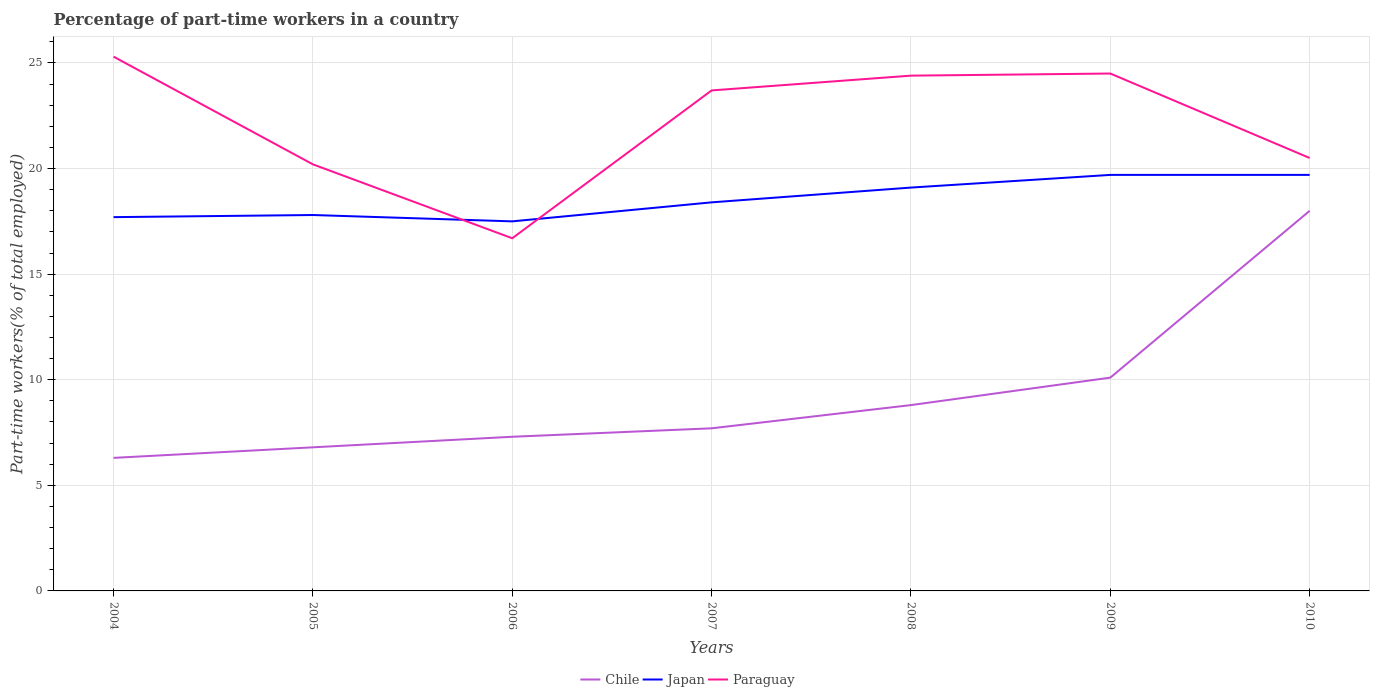Is the number of lines equal to the number of legend labels?
Your answer should be compact. Yes. Across all years, what is the maximum percentage of part-time workers in Japan?
Your response must be concise. 17.5. In which year was the percentage of part-time workers in Chile maximum?
Your answer should be compact. 2004. What is the difference between the highest and the second highest percentage of part-time workers in Paraguay?
Ensure brevity in your answer.  8.6. What is the difference between the highest and the lowest percentage of part-time workers in Chile?
Provide a short and direct response. 2. Is the percentage of part-time workers in Chile strictly greater than the percentage of part-time workers in Paraguay over the years?
Your answer should be very brief. Yes. How many lines are there?
Your answer should be very brief. 3. How many years are there in the graph?
Your response must be concise. 7. What is the difference between two consecutive major ticks on the Y-axis?
Make the answer very short. 5. Are the values on the major ticks of Y-axis written in scientific E-notation?
Provide a succinct answer. No. Does the graph contain grids?
Give a very brief answer. Yes. What is the title of the graph?
Keep it short and to the point. Percentage of part-time workers in a country. Does "Djibouti" appear as one of the legend labels in the graph?
Provide a succinct answer. No. What is the label or title of the X-axis?
Provide a succinct answer. Years. What is the label or title of the Y-axis?
Offer a terse response. Part-time workers(% of total employed). What is the Part-time workers(% of total employed) of Chile in 2004?
Ensure brevity in your answer.  6.3. What is the Part-time workers(% of total employed) of Japan in 2004?
Offer a terse response. 17.7. What is the Part-time workers(% of total employed) in Paraguay in 2004?
Your answer should be compact. 25.3. What is the Part-time workers(% of total employed) in Chile in 2005?
Provide a short and direct response. 6.8. What is the Part-time workers(% of total employed) in Japan in 2005?
Your answer should be very brief. 17.8. What is the Part-time workers(% of total employed) of Paraguay in 2005?
Provide a short and direct response. 20.2. What is the Part-time workers(% of total employed) of Chile in 2006?
Provide a succinct answer. 7.3. What is the Part-time workers(% of total employed) of Paraguay in 2006?
Offer a very short reply. 16.7. What is the Part-time workers(% of total employed) of Chile in 2007?
Ensure brevity in your answer.  7.7. What is the Part-time workers(% of total employed) of Japan in 2007?
Provide a short and direct response. 18.4. What is the Part-time workers(% of total employed) of Paraguay in 2007?
Keep it short and to the point. 23.7. What is the Part-time workers(% of total employed) of Chile in 2008?
Provide a short and direct response. 8.8. What is the Part-time workers(% of total employed) of Japan in 2008?
Your answer should be compact. 19.1. What is the Part-time workers(% of total employed) of Paraguay in 2008?
Offer a very short reply. 24.4. What is the Part-time workers(% of total employed) of Chile in 2009?
Make the answer very short. 10.1. What is the Part-time workers(% of total employed) in Japan in 2009?
Offer a terse response. 19.7. What is the Part-time workers(% of total employed) of Japan in 2010?
Your answer should be very brief. 19.7. Across all years, what is the maximum Part-time workers(% of total employed) of Chile?
Your answer should be compact. 18. Across all years, what is the maximum Part-time workers(% of total employed) of Japan?
Provide a succinct answer. 19.7. Across all years, what is the maximum Part-time workers(% of total employed) of Paraguay?
Keep it short and to the point. 25.3. Across all years, what is the minimum Part-time workers(% of total employed) in Chile?
Offer a very short reply. 6.3. Across all years, what is the minimum Part-time workers(% of total employed) of Paraguay?
Offer a very short reply. 16.7. What is the total Part-time workers(% of total employed) in Japan in the graph?
Provide a succinct answer. 129.9. What is the total Part-time workers(% of total employed) in Paraguay in the graph?
Ensure brevity in your answer.  155.3. What is the difference between the Part-time workers(% of total employed) of Chile in 2004 and that in 2005?
Your answer should be compact. -0.5. What is the difference between the Part-time workers(% of total employed) in Chile in 2004 and that in 2006?
Provide a succinct answer. -1. What is the difference between the Part-time workers(% of total employed) in Paraguay in 2004 and that in 2006?
Offer a very short reply. 8.6. What is the difference between the Part-time workers(% of total employed) in Japan in 2004 and that in 2007?
Provide a short and direct response. -0.7. What is the difference between the Part-time workers(% of total employed) of Paraguay in 2004 and that in 2007?
Offer a very short reply. 1.6. What is the difference between the Part-time workers(% of total employed) in Chile in 2004 and that in 2008?
Provide a succinct answer. -2.5. What is the difference between the Part-time workers(% of total employed) in Japan in 2004 and that in 2008?
Your response must be concise. -1.4. What is the difference between the Part-time workers(% of total employed) in Paraguay in 2004 and that in 2008?
Give a very brief answer. 0.9. What is the difference between the Part-time workers(% of total employed) of Chile in 2004 and that in 2009?
Your response must be concise. -3.8. What is the difference between the Part-time workers(% of total employed) in Japan in 2004 and that in 2009?
Keep it short and to the point. -2. What is the difference between the Part-time workers(% of total employed) of Paraguay in 2004 and that in 2010?
Make the answer very short. 4.8. What is the difference between the Part-time workers(% of total employed) of Japan in 2005 and that in 2006?
Keep it short and to the point. 0.3. What is the difference between the Part-time workers(% of total employed) in Paraguay in 2005 and that in 2006?
Keep it short and to the point. 3.5. What is the difference between the Part-time workers(% of total employed) in Chile in 2005 and that in 2007?
Offer a terse response. -0.9. What is the difference between the Part-time workers(% of total employed) of Japan in 2005 and that in 2007?
Ensure brevity in your answer.  -0.6. What is the difference between the Part-time workers(% of total employed) in Paraguay in 2005 and that in 2007?
Your answer should be very brief. -3.5. What is the difference between the Part-time workers(% of total employed) of Chile in 2005 and that in 2008?
Your answer should be compact. -2. What is the difference between the Part-time workers(% of total employed) of Japan in 2005 and that in 2008?
Provide a short and direct response. -1.3. What is the difference between the Part-time workers(% of total employed) of Paraguay in 2005 and that in 2009?
Give a very brief answer. -4.3. What is the difference between the Part-time workers(% of total employed) of Chile in 2005 and that in 2010?
Give a very brief answer. -11.2. What is the difference between the Part-time workers(% of total employed) in Japan in 2005 and that in 2010?
Make the answer very short. -1.9. What is the difference between the Part-time workers(% of total employed) in Paraguay in 2005 and that in 2010?
Offer a terse response. -0.3. What is the difference between the Part-time workers(% of total employed) of Chile in 2006 and that in 2007?
Offer a very short reply. -0.4. What is the difference between the Part-time workers(% of total employed) in Japan in 2006 and that in 2007?
Your response must be concise. -0.9. What is the difference between the Part-time workers(% of total employed) in Paraguay in 2006 and that in 2007?
Your response must be concise. -7. What is the difference between the Part-time workers(% of total employed) in Chile in 2006 and that in 2008?
Your answer should be compact. -1.5. What is the difference between the Part-time workers(% of total employed) in Paraguay in 2006 and that in 2008?
Make the answer very short. -7.7. What is the difference between the Part-time workers(% of total employed) of Japan in 2006 and that in 2009?
Your answer should be very brief. -2.2. What is the difference between the Part-time workers(% of total employed) of Paraguay in 2006 and that in 2009?
Make the answer very short. -7.8. What is the difference between the Part-time workers(% of total employed) in Chile in 2006 and that in 2010?
Ensure brevity in your answer.  -10.7. What is the difference between the Part-time workers(% of total employed) in Japan in 2006 and that in 2010?
Offer a very short reply. -2.2. What is the difference between the Part-time workers(% of total employed) of Paraguay in 2006 and that in 2010?
Give a very brief answer. -3.8. What is the difference between the Part-time workers(% of total employed) in Japan in 2007 and that in 2009?
Make the answer very short. -1.3. What is the difference between the Part-time workers(% of total employed) of Paraguay in 2007 and that in 2009?
Your answer should be very brief. -0.8. What is the difference between the Part-time workers(% of total employed) in Chile in 2007 and that in 2010?
Make the answer very short. -10.3. What is the difference between the Part-time workers(% of total employed) of Japan in 2007 and that in 2010?
Give a very brief answer. -1.3. What is the difference between the Part-time workers(% of total employed) in Japan in 2009 and that in 2010?
Offer a terse response. 0. What is the difference between the Part-time workers(% of total employed) in Chile in 2004 and the Part-time workers(% of total employed) in Japan in 2005?
Your answer should be compact. -11.5. What is the difference between the Part-time workers(% of total employed) in Chile in 2004 and the Part-time workers(% of total employed) in Paraguay in 2005?
Provide a short and direct response. -13.9. What is the difference between the Part-time workers(% of total employed) of Chile in 2004 and the Part-time workers(% of total employed) of Japan in 2006?
Keep it short and to the point. -11.2. What is the difference between the Part-time workers(% of total employed) in Chile in 2004 and the Part-time workers(% of total employed) in Paraguay in 2006?
Your answer should be very brief. -10.4. What is the difference between the Part-time workers(% of total employed) in Chile in 2004 and the Part-time workers(% of total employed) in Japan in 2007?
Offer a terse response. -12.1. What is the difference between the Part-time workers(% of total employed) in Chile in 2004 and the Part-time workers(% of total employed) in Paraguay in 2007?
Offer a terse response. -17.4. What is the difference between the Part-time workers(% of total employed) in Japan in 2004 and the Part-time workers(% of total employed) in Paraguay in 2007?
Your answer should be very brief. -6. What is the difference between the Part-time workers(% of total employed) of Chile in 2004 and the Part-time workers(% of total employed) of Paraguay in 2008?
Keep it short and to the point. -18.1. What is the difference between the Part-time workers(% of total employed) in Chile in 2004 and the Part-time workers(% of total employed) in Paraguay in 2009?
Provide a succinct answer. -18.2. What is the difference between the Part-time workers(% of total employed) in Chile in 2004 and the Part-time workers(% of total employed) in Japan in 2010?
Provide a short and direct response. -13.4. What is the difference between the Part-time workers(% of total employed) in Chile in 2005 and the Part-time workers(% of total employed) in Paraguay in 2006?
Your answer should be compact. -9.9. What is the difference between the Part-time workers(% of total employed) in Japan in 2005 and the Part-time workers(% of total employed) in Paraguay in 2006?
Offer a terse response. 1.1. What is the difference between the Part-time workers(% of total employed) in Chile in 2005 and the Part-time workers(% of total employed) in Japan in 2007?
Provide a short and direct response. -11.6. What is the difference between the Part-time workers(% of total employed) in Chile in 2005 and the Part-time workers(% of total employed) in Paraguay in 2007?
Make the answer very short. -16.9. What is the difference between the Part-time workers(% of total employed) in Japan in 2005 and the Part-time workers(% of total employed) in Paraguay in 2007?
Your response must be concise. -5.9. What is the difference between the Part-time workers(% of total employed) of Chile in 2005 and the Part-time workers(% of total employed) of Paraguay in 2008?
Provide a short and direct response. -17.6. What is the difference between the Part-time workers(% of total employed) of Japan in 2005 and the Part-time workers(% of total employed) of Paraguay in 2008?
Provide a short and direct response. -6.6. What is the difference between the Part-time workers(% of total employed) of Chile in 2005 and the Part-time workers(% of total employed) of Japan in 2009?
Your answer should be very brief. -12.9. What is the difference between the Part-time workers(% of total employed) in Chile in 2005 and the Part-time workers(% of total employed) in Paraguay in 2009?
Your answer should be compact. -17.7. What is the difference between the Part-time workers(% of total employed) of Chile in 2005 and the Part-time workers(% of total employed) of Japan in 2010?
Give a very brief answer. -12.9. What is the difference between the Part-time workers(% of total employed) of Chile in 2005 and the Part-time workers(% of total employed) of Paraguay in 2010?
Provide a succinct answer. -13.7. What is the difference between the Part-time workers(% of total employed) of Japan in 2005 and the Part-time workers(% of total employed) of Paraguay in 2010?
Offer a terse response. -2.7. What is the difference between the Part-time workers(% of total employed) of Chile in 2006 and the Part-time workers(% of total employed) of Paraguay in 2007?
Provide a short and direct response. -16.4. What is the difference between the Part-time workers(% of total employed) of Chile in 2006 and the Part-time workers(% of total employed) of Japan in 2008?
Your response must be concise. -11.8. What is the difference between the Part-time workers(% of total employed) in Chile in 2006 and the Part-time workers(% of total employed) in Paraguay in 2008?
Your response must be concise. -17.1. What is the difference between the Part-time workers(% of total employed) in Chile in 2006 and the Part-time workers(% of total employed) in Japan in 2009?
Keep it short and to the point. -12.4. What is the difference between the Part-time workers(% of total employed) in Chile in 2006 and the Part-time workers(% of total employed) in Paraguay in 2009?
Offer a very short reply. -17.2. What is the difference between the Part-time workers(% of total employed) in Japan in 2006 and the Part-time workers(% of total employed) in Paraguay in 2009?
Provide a short and direct response. -7. What is the difference between the Part-time workers(% of total employed) of Chile in 2006 and the Part-time workers(% of total employed) of Japan in 2010?
Offer a very short reply. -12.4. What is the difference between the Part-time workers(% of total employed) of Chile in 2006 and the Part-time workers(% of total employed) of Paraguay in 2010?
Offer a terse response. -13.2. What is the difference between the Part-time workers(% of total employed) in Japan in 2006 and the Part-time workers(% of total employed) in Paraguay in 2010?
Your response must be concise. -3. What is the difference between the Part-time workers(% of total employed) in Chile in 2007 and the Part-time workers(% of total employed) in Paraguay in 2008?
Ensure brevity in your answer.  -16.7. What is the difference between the Part-time workers(% of total employed) in Chile in 2007 and the Part-time workers(% of total employed) in Paraguay in 2009?
Your answer should be very brief. -16.8. What is the difference between the Part-time workers(% of total employed) of Chile in 2007 and the Part-time workers(% of total employed) of Japan in 2010?
Ensure brevity in your answer.  -12. What is the difference between the Part-time workers(% of total employed) of Chile in 2007 and the Part-time workers(% of total employed) of Paraguay in 2010?
Offer a terse response. -12.8. What is the difference between the Part-time workers(% of total employed) in Japan in 2007 and the Part-time workers(% of total employed) in Paraguay in 2010?
Your response must be concise. -2.1. What is the difference between the Part-time workers(% of total employed) of Chile in 2008 and the Part-time workers(% of total employed) of Paraguay in 2009?
Provide a succinct answer. -15.7. What is the difference between the Part-time workers(% of total employed) in Chile in 2008 and the Part-time workers(% of total employed) in Japan in 2010?
Give a very brief answer. -10.9. What is the difference between the Part-time workers(% of total employed) in Japan in 2008 and the Part-time workers(% of total employed) in Paraguay in 2010?
Offer a terse response. -1.4. What is the difference between the Part-time workers(% of total employed) in Chile in 2009 and the Part-time workers(% of total employed) in Paraguay in 2010?
Provide a short and direct response. -10.4. What is the difference between the Part-time workers(% of total employed) of Japan in 2009 and the Part-time workers(% of total employed) of Paraguay in 2010?
Provide a short and direct response. -0.8. What is the average Part-time workers(% of total employed) of Chile per year?
Make the answer very short. 9.29. What is the average Part-time workers(% of total employed) of Japan per year?
Ensure brevity in your answer.  18.56. What is the average Part-time workers(% of total employed) in Paraguay per year?
Provide a succinct answer. 22.19. In the year 2005, what is the difference between the Part-time workers(% of total employed) of Japan and Part-time workers(% of total employed) of Paraguay?
Ensure brevity in your answer.  -2.4. In the year 2006, what is the difference between the Part-time workers(% of total employed) in Chile and Part-time workers(% of total employed) in Japan?
Give a very brief answer. -10.2. In the year 2007, what is the difference between the Part-time workers(% of total employed) of Chile and Part-time workers(% of total employed) of Japan?
Your answer should be compact. -10.7. In the year 2008, what is the difference between the Part-time workers(% of total employed) in Chile and Part-time workers(% of total employed) in Paraguay?
Give a very brief answer. -15.6. In the year 2009, what is the difference between the Part-time workers(% of total employed) in Chile and Part-time workers(% of total employed) in Japan?
Make the answer very short. -9.6. In the year 2009, what is the difference between the Part-time workers(% of total employed) of Chile and Part-time workers(% of total employed) of Paraguay?
Your answer should be compact. -14.4. In the year 2009, what is the difference between the Part-time workers(% of total employed) of Japan and Part-time workers(% of total employed) of Paraguay?
Ensure brevity in your answer.  -4.8. In the year 2010, what is the difference between the Part-time workers(% of total employed) of Chile and Part-time workers(% of total employed) of Paraguay?
Give a very brief answer. -2.5. What is the ratio of the Part-time workers(% of total employed) of Chile in 2004 to that in 2005?
Keep it short and to the point. 0.93. What is the ratio of the Part-time workers(% of total employed) in Paraguay in 2004 to that in 2005?
Offer a very short reply. 1.25. What is the ratio of the Part-time workers(% of total employed) of Chile in 2004 to that in 2006?
Provide a succinct answer. 0.86. What is the ratio of the Part-time workers(% of total employed) of Japan in 2004 to that in 2006?
Your response must be concise. 1.01. What is the ratio of the Part-time workers(% of total employed) in Paraguay in 2004 to that in 2006?
Offer a very short reply. 1.51. What is the ratio of the Part-time workers(% of total employed) of Chile in 2004 to that in 2007?
Keep it short and to the point. 0.82. What is the ratio of the Part-time workers(% of total employed) in Japan in 2004 to that in 2007?
Keep it short and to the point. 0.96. What is the ratio of the Part-time workers(% of total employed) in Paraguay in 2004 to that in 2007?
Offer a very short reply. 1.07. What is the ratio of the Part-time workers(% of total employed) of Chile in 2004 to that in 2008?
Your response must be concise. 0.72. What is the ratio of the Part-time workers(% of total employed) in Japan in 2004 to that in 2008?
Your response must be concise. 0.93. What is the ratio of the Part-time workers(% of total employed) in Paraguay in 2004 to that in 2008?
Provide a short and direct response. 1.04. What is the ratio of the Part-time workers(% of total employed) of Chile in 2004 to that in 2009?
Your response must be concise. 0.62. What is the ratio of the Part-time workers(% of total employed) in Japan in 2004 to that in 2009?
Provide a short and direct response. 0.9. What is the ratio of the Part-time workers(% of total employed) of Paraguay in 2004 to that in 2009?
Give a very brief answer. 1.03. What is the ratio of the Part-time workers(% of total employed) in Chile in 2004 to that in 2010?
Provide a short and direct response. 0.35. What is the ratio of the Part-time workers(% of total employed) of Japan in 2004 to that in 2010?
Offer a terse response. 0.9. What is the ratio of the Part-time workers(% of total employed) of Paraguay in 2004 to that in 2010?
Provide a short and direct response. 1.23. What is the ratio of the Part-time workers(% of total employed) of Chile in 2005 to that in 2006?
Offer a very short reply. 0.93. What is the ratio of the Part-time workers(% of total employed) in Japan in 2005 to that in 2006?
Offer a very short reply. 1.02. What is the ratio of the Part-time workers(% of total employed) in Paraguay in 2005 to that in 2006?
Keep it short and to the point. 1.21. What is the ratio of the Part-time workers(% of total employed) in Chile in 2005 to that in 2007?
Make the answer very short. 0.88. What is the ratio of the Part-time workers(% of total employed) of Japan in 2005 to that in 2007?
Offer a terse response. 0.97. What is the ratio of the Part-time workers(% of total employed) of Paraguay in 2005 to that in 2007?
Offer a terse response. 0.85. What is the ratio of the Part-time workers(% of total employed) in Chile in 2005 to that in 2008?
Your answer should be very brief. 0.77. What is the ratio of the Part-time workers(% of total employed) in Japan in 2005 to that in 2008?
Give a very brief answer. 0.93. What is the ratio of the Part-time workers(% of total employed) of Paraguay in 2005 to that in 2008?
Provide a short and direct response. 0.83. What is the ratio of the Part-time workers(% of total employed) of Chile in 2005 to that in 2009?
Your answer should be very brief. 0.67. What is the ratio of the Part-time workers(% of total employed) of Japan in 2005 to that in 2009?
Ensure brevity in your answer.  0.9. What is the ratio of the Part-time workers(% of total employed) of Paraguay in 2005 to that in 2009?
Provide a succinct answer. 0.82. What is the ratio of the Part-time workers(% of total employed) in Chile in 2005 to that in 2010?
Your answer should be compact. 0.38. What is the ratio of the Part-time workers(% of total employed) of Japan in 2005 to that in 2010?
Offer a terse response. 0.9. What is the ratio of the Part-time workers(% of total employed) in Paraguay in 2005 to that in 2010?
Offer a very short reply. 0.99. What is the ratio of the Part-time workers(% of total employed) in Chile in 2006 to that in 2007?
Keep it short and to the point. 0.95. What is the ratio of the Part-time workers(% of total employed) of Japan in 2006 to that in 2007?
Offer a terse response. 0.95. What is the ratio of the Part-time workers(% of total employed) of Paraguay in 2006 to that in 2007?
Keep it short and to the point. 0.7. What is the ratio of the Part-time workers(% of total employed) of Chile in 2006 to that in 2008?
Provide a short and direct response. 0.83. What is the ratio of the Part-time workers(% of total employed) of Japan in 2006 to that in 2008?
Give a very brief answer. 0.92. What is the ratio of the Part-time workers(% of total employed) in Paraguay in 2006 to that in 2008?
Provide a short and direct response. 0.68. What is the ratio of the Part-time workers(% of total employed) in Chile in 2006 to that in 2009?
Give a very brief answer. 0.72. What is the ratio of the Part-time workers(% of total employed) in Japan in 2006 to that in 2009?
Ensure brevity in your answer.  0.89. What is the ratio of the Part-time workers(% of total employed) of Paraguay in 2006 to that in 2009?
Your response must be concise. 0.68. What is the ratio of the Part-time workers(% of total employed) of Chile in 2006 to that in 2010?
Provide a succinct answer. 0.41. What is the ratio of the Part-time workers(% of total employed) of Japan in 2006 to that in 2010?
Offer a terse response. 0.89. What is the ratio of the Part-time workers(% of total employed) in Paraguay in 2006 to that in 2010?
Give a very brief answer. 0.81. What is the ratio of the Part-time workers(% of total employed) of Chile in 2007 to that in 2008?
Your answer should be very brief. 0.88. What is the ratio of the Part-time workers(% of total employed) of Japan in 2007 to that in 2008?
Offer a very short reply. 0.96. What is the ratio of the Part-time workers(% of total employed) in Paraguay in 2007 to that in 2008?
Offer a terse response. 0.97. What is the ratio of the Part-time workers(% of total employed) of Chile in 2007 to that in 2009?
Ensure brevity in your answer.  0.76. What is the ratio of the Part-time workers(% of total employed) of Japan in 2007 to that in 2009?
Offer a very short reply. 0.93. What is the ratio of the Part-time workers(% of total employed) in Paraguay in 2007 to that in 2009?
Keep it short and to the point. 0.97. What is the ratio of the Part-time workers(% of total employed) of Chile in 2007 to that in 2010?
Make the answer very short. 0.43. What is the ratio of the Part-time workers(% of total employed) of Japan in 2007 to that in 2010?
Keep it short and to the point. 0.93. What is the ratio of the Part-time workers(% of total employed) in Paraguay in 2007 to that in 2010?
Make the answer very short. 1.16. What is the ratio of the Part-time workers(% of total employed) in Chile in 2008 to that in 2009?
Your answer should be compact. 0.87. What is the ratio of the Part-time workers(% of total employed) of Japan in 2008 to that in 2009?
Provide a succinct answer. 0.97. What is the ratio of the Part-time workers(% of total employed) in Paraguay in 2008 to that in 2009?
Your answer should be compact. 1. What is the ratio of the Part-time workers(% of total employed) in Chile in 2008 to that in 2010?
Your answer should be compact. 0.49. What is the ratio of the Part-time workers(% of total employed) in Japan in 2008 to that in 2010?
Keep it short and to the point. 0.97. What is the ratio of the Part-time workers(% of total employed) of Paraguay in 2008 to that in 2010?
Provide a succinct answer. 1.19. What is the ratio of the Part-time workers(% of total employed) of Chile in 2009 to that in 2010?
Offer a terse response. 0.56. What is the ratio of the Part-time workers(% of total employed) of Paraguay in 2009 to that in 2010?
Offer a very short reply. 1.2. What is the difference between the highest and the lowest Part-time workers(% of total employed) of Chile?
Your response must be concise. 11.7. What is the difference between the highest and the lowest Part-time workers(% of total employed) in Paraguay?
Provide a short and direct response. 8.6. 